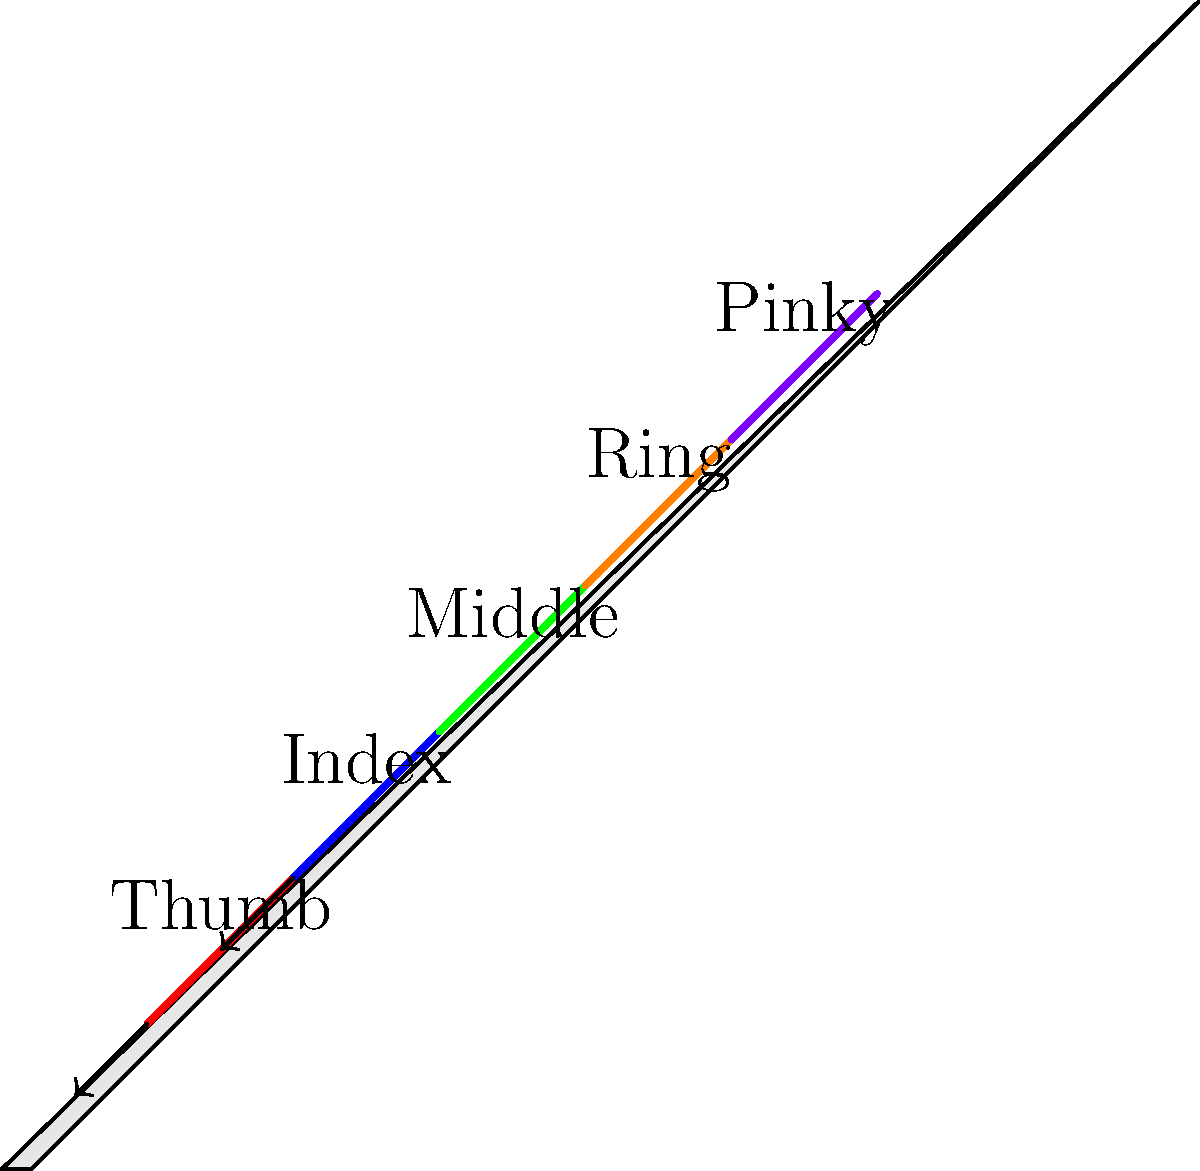During a DJ scratching technique, which finger is primarily responsible for applying pressure to the vinyl record, and what type of joint movement is most crucial for this action? To answer this question, let's break down the biomechanics of DJ scratching:

1. Hand position: The DJ's hand is typically placed on top of the vinyl record, with the thumb on one side and the other fingers spread across the record's surface.

2. Primary pressure application: The index finger is the main digit responsible for applying pressure to the vinyl record during scratching techniques. This is due to its strength, dexterity, and position on the hand.

3. Joint movement: The most crucial joint movement for this action is the flexion and extension of the metacarpophalangeal (MCP) joint of the index finger. This joint is located at the base of the finger where it meets the hand.

4. Biomechanics of the movement:
   a) Flexion: The MCP joint bends, allowing the finger to press down on the vinyl.
   b) Extension: The MCP joint straightens, releasing pressure from the vinyl.

5. Supporting movements:
   a) The interphalangeal (IP) joints of the index finger provide fine control.
   b) The thumb often acts as a stabilizer and may assist in controlling the record's movement.
   c) The wrist and forearm contribute to the overall scratching motion.

6. Muscle groups involved:
   a) Flexor digitorum superficialis and profundus: for finger flexion
   b) Extensor digitorum: for finger extension
   c) Intrinsic hand muscles: for fine motor control

The rapid alternation between flexion and extension of the index finger's MCP joint, combined with the arm and wrist movements, creates the characteristic scratching sound and effect.
Answer: Index finger; flexion and extension of the metacarpophalangeal (MCP) joint 